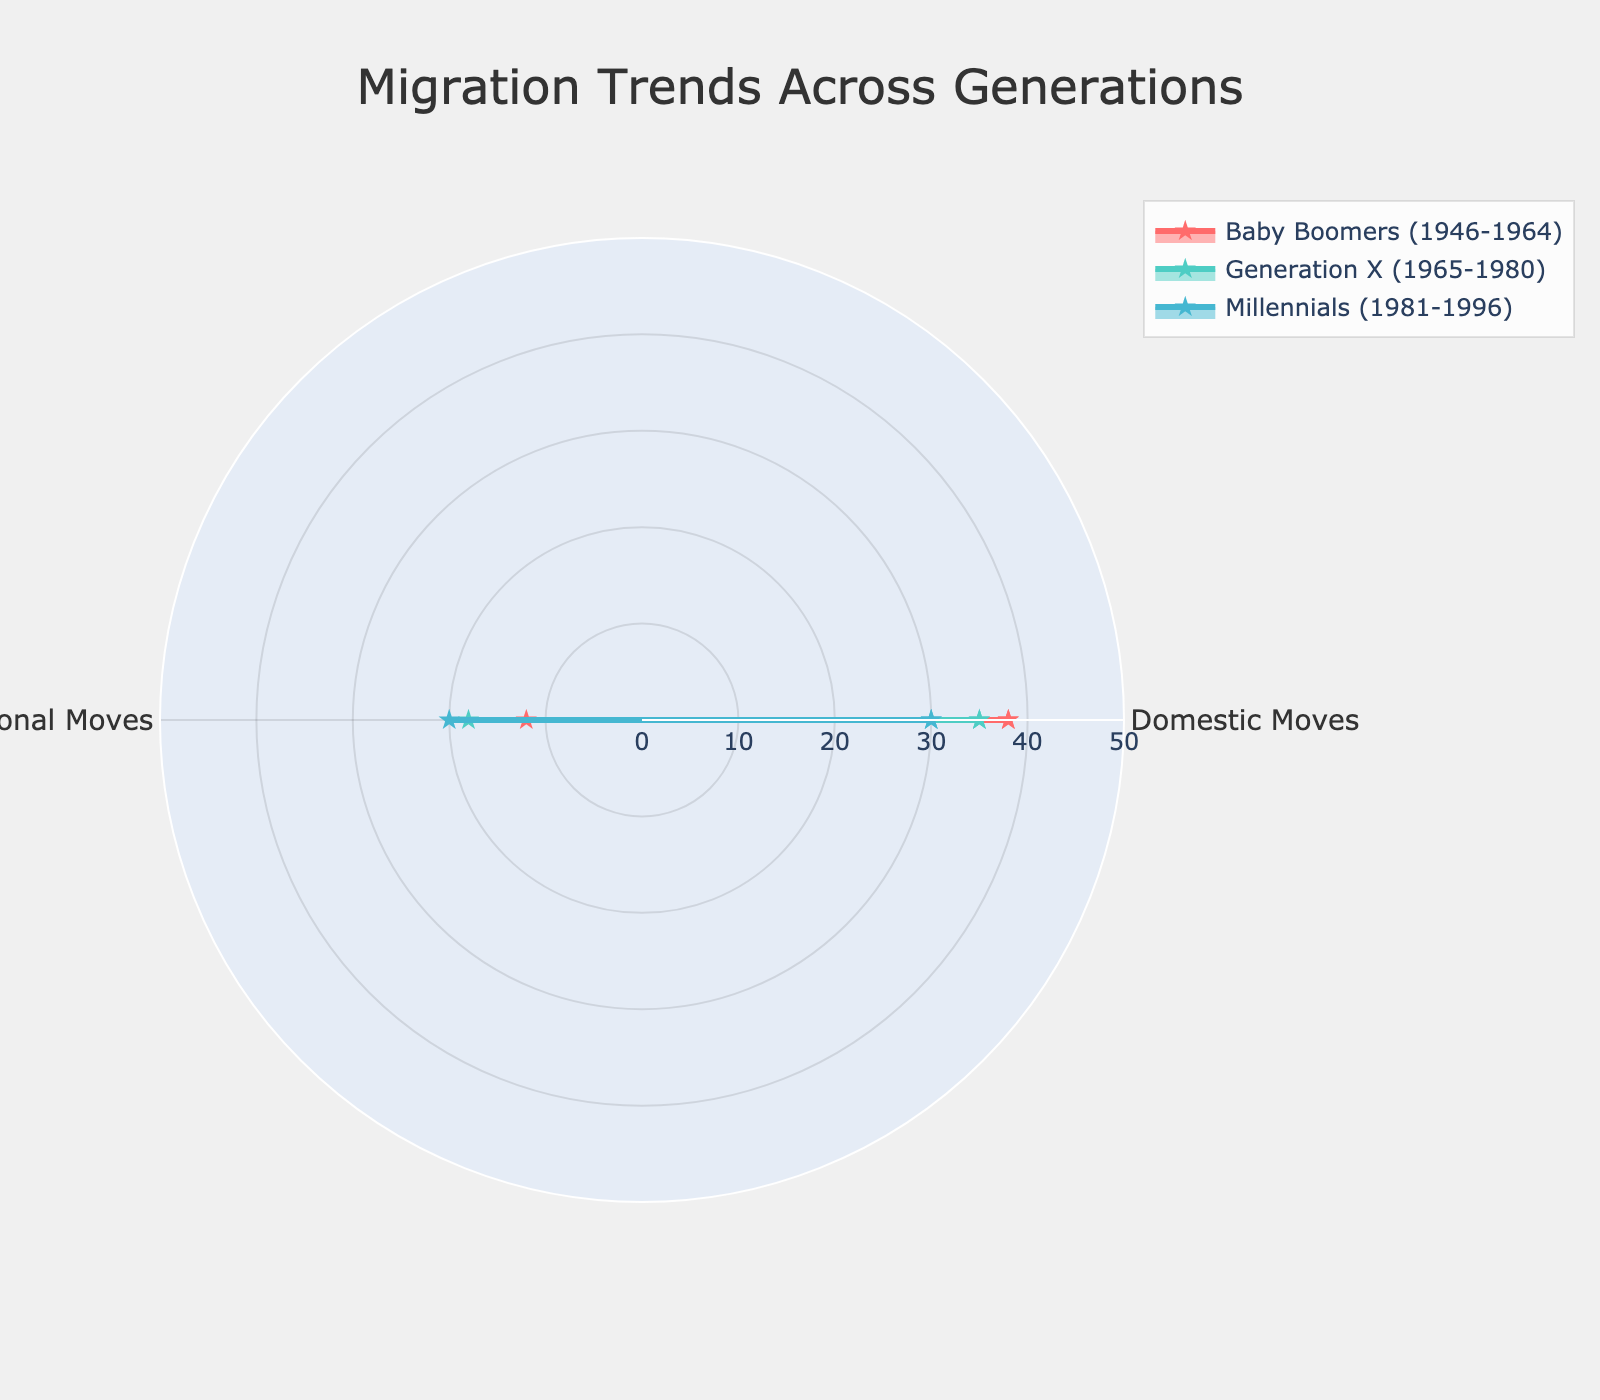What is the title of the chart? The title of the chart is centered at the top of the figure.
Answer: Migration Trends Across Generations What are the two categories represented in the radar chart? The radar chart displays data along two axes which are labeled.
Answer: Domestic Moves, International Moves Which generation has the highest number of international moves? By comparing the values along the "International Moves" axis for each of the three generations (Baby Boomers, Generation X, Millennials), the highest number can be identified.
Answer: Millennials What is the primary color used for Generation X's data in the plot? Each generation's data is shown with a distinct color, visible in the plot and legend.
Answer: Turquoise Which generation shows the smallest difference between domestic and international moves? Calculate the difference between "Domestic Moves" and "International Moves" for each selected generation. Then, compare these differences to find the smallest one.
Answer: Millennials What is the approximate average of domestic moves across the three generations shown? Add the domestic moves for the three generations together and then divide by the number of generations (3). The values are 38 for Baby Boomers, 35 for Generation X, and 30 for Millennials. Calculation: (38 + 35 + 30) / 3.
Answer: 34.3 Compare the trends in domestic moves and international moves for Baby Boomers and Millennials. Who tends to move more internationally? Look at the values for "International Moves" for Baby Boomers and Millennials.
Answer: Millennials What is the total number of domestic and international moves for Generation X? Sum up the values of "Domestic Moves" and "International Moves" for Generation X. Calculation: 35 + 18.
Answer: 53 How does the migration trend between Baby Boomers and Generation X differ for international moves? Compare the "International Moves" data points for Baby Boomers and Generation X directly from the chart.
Answer: Generation X has more international moves than Baby Boomers How many points in total are plotted in the radar chart? Count the number of data points for each of the two categories across the three generations. Each generation has two data points (Domestic Moves and International Moves), making a total of three generations times two data points each. Calculation: 3 * 2.
Answer: 6 